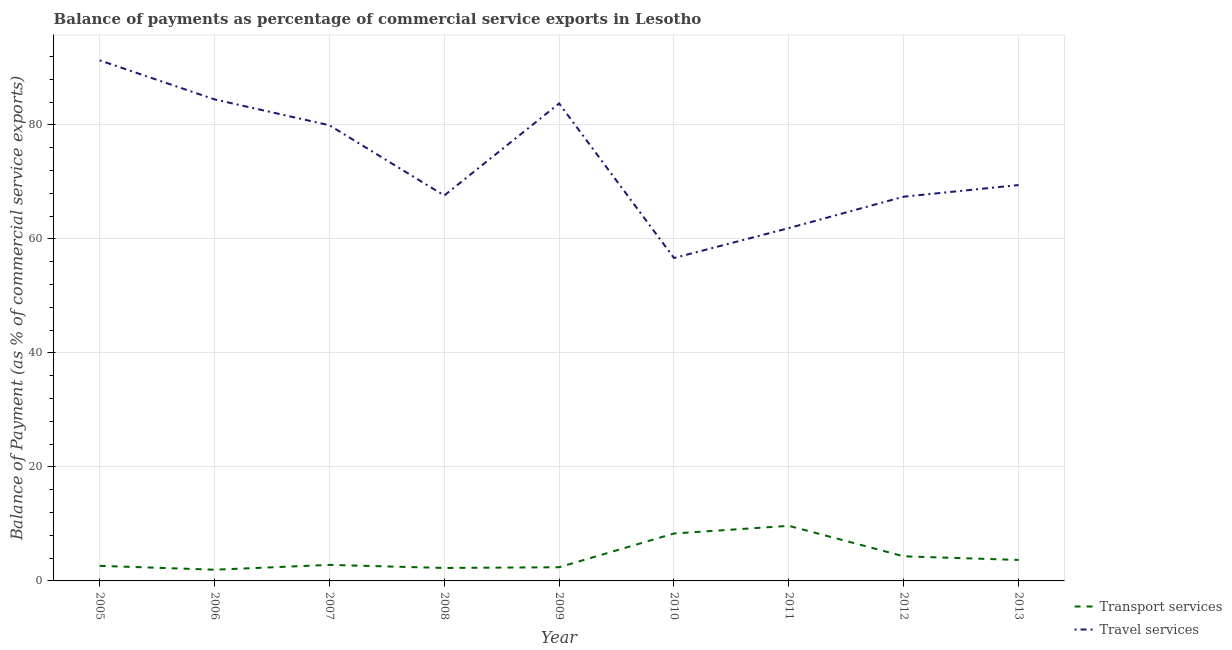Does the line corresponding to balance of payments of transport services intersect with the line corresponding to balance of payments of travel services?
Offer a very short reply. No. What is the balance of payments of travel services in 2009?
Make the answer very short. 83.77. Across all years, what is the maximum balance of payments of transport services?
Provide a succinct answer. 9.67. Across all years, what is the minimum balance of payments of travel services?
Provide a short and direct response. 56.66. What is the total balance of payments of travel services in the graph?
Your response must be concise. 662.61. What is the difference between the balance of payments of travel services in 2008 and that in 2011?
Keep it short and to the point. 5.71. What is the difference between the balance of payments of transport services in 2010 and the balance of payments of travel services in 2008?
Make the answer very short. -59.3. What is the average balance of payments of transport services per year?
Keep it short and to the point. 4.23. In the year 2008, what is the difference between the balance of payments of transport services and balance of payments of travel services?
Your response must be concise. -65.34. What is the ratio of the balance of payments of transport services in 2005 to that in 2008?
Provide a succinct answer. 1.16. Is the balance of payments of travel services in 2010 less than that in 2013?
Ensure brevity in your answer.  Yes. What is the difference between the highest and the second highest balance of payments of transport services?
Give a very brief answer. 1.34. What is the difference between the highest and the lowest balance of payments of transport services?
Keep it short and to the point. 7.7. Is the sum of the balance of payments of transport services in 2010 and 2013 greater than the maximum balance of payments of travel services across all years?
Keep it short and to the point. No. Is the balance of payments of transport services strictly less than the balance of payments of travel services over the years?
Provide a short and direct response. Yes. How many lines are there?
Make the answer very short. 2. Are the values on the major ticks of Y-axis written in scientific E-notation?
Your answer should be very brief. No. How many legend labels are there?
Offer a terse response. 2. What is the title of the graph?
Your answer should be very brief. Balance of payments as percentage of commercial service exports in Lesotho. Does "Nitrous oxide emissions" appear as one of the legend labels in the graph?
Ensure brevity in your answer.  No. What is the label or title of the X-axis?
Offer a very short reply. Year. What is the label or title of the Y-axis?
Make the answer very short. Balance of Payment (as % of commercial service exports). What is the Balance of Payment (as % of commercial service exports) of Transport services in 2005?
Provide a succinct answer. 2.64. What is the Balance of Payment (as % of commercial service exports) of Travel services in 2005?
Provide a succinct answer. 91.34. What is the Balance of Payment (as % of commercial service exports) of Transport services in 2006?
Your answer should be compact. 1.97. What is the Balance of Payment (as % of commercial service exports) in Travel services in 2006?
Make the answer very short. 84.49. What is the Balance of Payment (as % of commercial service exports) in Transport services in 2007?
Offer a terse response. 2.81. What is the Balance of Payment (as % of commercial service exports) in Travel services in 2007?
Your response must be concise. 79.95. What is the Balance of Payment (as % of commercial service exports) of Transport services in 2008?
Give a very brief answer. 2.27. What is the Balance of Payment (as % of commercial service exports) of Travel services in 2008?
Your response must be concise. 67.62. What is the Balance of Payment (as % of commercial service exports) of Transport services in 2009?
Your answer should be very brief. 2.4. What is the Balance of Payment (as % of commercial service exports) of Travel services in 2009?
Keep it short and to the point. 83.77. What is the Balance of Payment (as % of commercial service exports) in Transport services in 2010?
Provide a short and direct response. 8.32. What is the Balance of Payment (as % of commercial service exports) of Travel services in 2010?
Provide a succinct answer. 56.66. What is the Balance of Payment (as % of commercial service exports) in Transport services in 2011?
Provide a succinct answer. 9.67. What is the Balance of Payment (as % of commercial service exports) in Travel services in 2011?
Ensure brevity in your answer.  61.91. What is the Balance of Payment (as % of commercial service exports) of Transport services in 2012?
Give a very brief answer. 4.32. What is the Balance of Payment (as % of commercial service exports) in Travel services in 2012?
Your response must be concise. 67.42. What is the Balance of Payment (as % of commercial service exports) in Transport services in 2013?
Keep it short and to the point. 3.68. What is the Balance of Payment (as % of commercial service exports) of Travel services in 2013?
Your answer should be very brief. 69.46. Across all years, what is the maximum Balance of Payment (as % of commercial service exports) of Transport services?
Give a very brief answer. 9.67. Across all years, what is the maximum Balance of Payment (as % of commercial service exports) in Travel services?
Your response must be concise. 91.34. Across all years, what is the minimum Balance of Payment (as % of commercial service exports) in Transport services?
Make the answer very short. 1.97. Across all years, what is the minimum Balance of Payment (as % of commercial service exports) in Travel services?
Ensure brevity in your answer.  56.66. What is the total Balance of Payment (as % of commercial service exports) in Transport services in the graph?
Your answer should be very brief. 38.09. What is the total Balance of Payment (as % of commercial service exports) in Travel services in the graph?
Provide a succinct answer. 662.61. What is the difference between the Balance of Payment (as % of commercial service exports) of Transport services in 2005 and that in 2006?
Give a very brief answer. 0.68. What is the difference between the Balance of Payment (as % of commercial service exports) of Travel services in 2005 and that in 2006?
Give a very brief answer. 6.85. What is the difference between the Balance of Payment (as % of commercial service exports) in Transport services in 2005 and that in 2007?
Provide a succinct answer. -0.17. What is the difference between the Balance of Payment (as % of commercial service exports) in Travel services in 2005 and that in 2007?
Give a very brief answer. 11.39. What is the difference between the Balance of Payment (as % of commercial service exports) in Transport services in 2005 and that in 2008?
Your response must be concise. 0.37. What is the difference between the Balance of Payment (as % of commercial service exports) of Travel services in 2005 and that in 2008?
Provide a short and direct response. 23.72. What is the difference between the Balance of Payment (as % of commercial service exports) in Transport services in 2005 and that in 2009?
Keep it short and to the point. 0.24. What is the difference between the Balance of Payment (as % of commercial service exports) in Travel services in 2005 and that in 2009?
Offer a very short reply. 7.57. What is the difference between the Balance of Payment (as % of commercial service exports) in Transport services in 2005 and that in 2010?
Your answer should be compact. -5.68. What is the difference between the Balance of Payment (as % of commercial service exports) in Travel services in 2005 and that in 2010?
Offer a very short reply. 34.68. What is the difference between the Balance of Payment (as % of commercial service exports) of Transport services in 2005 and that in 2011?
Your response must be concise. -7.02. What is the difference between the Balance of Payment (as % of commercial service exports) in Travel services in 2005 and that in 2011?
Give a very brief answer. 29.43. What is the difference between the Balance of Payment (as % of commercial service exports) of Transport services in 2005 and that in 2012?
Your response must be concise. -1.67. What is the difference between the Balance of Payment (as % of commercial service exports) in Travel services in 2005 and that in 2012?
Your response must be concise. 23.92. What is the difference between the Balance of Payment (as % of commercial service exports) of Transport services in 2005 and that in 2013?
Provide a short and direct response. -1.04. What is the difference between the Balance of Payment (as % of commercial service exports) in Travel services in 2005 and that in 2013?
Give a very brief answer. 21.88. What is the difference between the Balance of Payment (as % of commercial service exports) in Transport services in 2006 and that in 2007?
Keep it short and to the point. -0.84. What is the difference between the Balance of Payment (as % of commercial service exports) of Travel services in 2006 and that in 2007?
Your response must be concise. 4.54. What is the difference between the Balance of Payment (as % of commercial service exports) in Transport services in 2006 and that in 2008?
Your answer should be very brief. -0.31. What is the difference between the Balance of Payment (as % of commercial service exports) of Travel services in 2006 and that in 2008?
Make the answer very short. 16.87. What is the difference between the Balance of Payment (as % of commercial service exports) in Transport services in 2006 and that in 2009?
Make the answer very short. -0.43. What is the difference between the Balance of Payment (as % of commercial service exports) of Travel services in 2006 and that in 2009?
Your answer should be very brief. 0.72. What is the difference between the Balance of Payment (as % of commercial service exports) in Transport services in 2006 and that in 2010?
Your answer should be compact. -6.35. What is the difference between the Balance of Payment (as % of commercial service exports) in Travel services in 2006 and that in 2010?
Your answer should be very brief. 27.83. What is the difference between the Balance of Payment (as % of commercial service exports) of Transport services in 2006 and that in 2011?
Give a very brief answer. -7.7. What is the difference between the Balance of Payment (as % of commercial service exports) of Travel services in 2006 and that in 2011?
Your answer should be very brief. 22.58. What is the difference between the Balance of Payment (as % of commercial service exports) in Transport services in 2006 and that in 2012?
Your answer should be compact. -2.35. What is the difference between the Balance of Payment (as % of commercial service exports) in Travel services in 2006 and that in 2012?
Provide a short and direct response. 17.07. What is the difference between the Balance of Payment (as % of commercial service exports) in Transport services in 2006 and that in 2013?
Your answer should be very brief. -1.71. What is the difference between the Balance of Payment (as % of commercial service exports) in Travel services in 2006 and that in 2013?
Your answer should be compact. 15.03. What is the difference between the Balance of Payment (as % of commercial service exports) of Transport services in 2007 and that in 2008?
Give a very brief answer. 0.54. What is the difference between the Balance of Payment (as % of commercial service exports) of Travel services in 2007 and that in 2008?
Your answer should be very brief. 12.33. What is the difference between the Balance of Payment (as % of commercial service exports) of Transport services in 2007 and that in 2009?
Your answer should be compact. 0.41. What is the difference between the Balance of Payment (as % of commercial service exports) in Travel services in 2007 and that in 2009?
Keep it short and to the point. -3.82. What is the difference between the Balance of Payment (as % of commercial service exports) of Transport services in 2007 and that in 2010?
Keep it short and to the point. -5.51. What is the difference between the Balance of Payment (as % of commercial service exports) in Travel services in 2007 and that in 2010?
Offer a terse response. 23.29. What is the difference between the Balance of Payment (as % of commercial service exports) in Transport services in 2007 and that in 2011?
Give a very brief answer. -6.85. What is the difference between the Balance of Payment (as % of commercial service exports) of Travel services in 2007 and that in 2011?
Offer a very short reply. 18.04. What is the difference between the Balance of Payment (as % of commercial service exports) in Transport services in 2007 and that in 2012?
Offer a very short reply. -1.5. What is the difference between the Balance of Payment (as % of commercial service exports) of Travel services in 2007 and that in 2012?
Make the answer very short. 12.53. What is the difference between the Balance of Payment (as % of commercial service exports) of Transport services in 2007 and that in 2013?
Make the answer very short. -0.87. What is the difference between the Balance of Payment (as % of commercial service exports) in Travel services in 2007 and that in 2013?
Your answer should be very brief. 10.5. What is the difference between the Balance of Payment (as % of commercial service exports) of Transport services in 2008 and that in 2009?
Give a very brief answer. -0.13. What is the difference between the Balance of Payment (as % of commercial service exports) in Travel services in 2008 and that in 2009?
Ensure brevity in your answer.  -16.15. What is the difference between the Balance of Payment (as % of commercial service exports) in Transport services in 2008 and that in 2010?
Give a very brief answer. -6.05. What is the difference between the Balance of Payment (as % of commercial service exports) of Travel services in 2008 and that in 2010?
Provide a short and direct response. 10.96. What is the difference between the Balance of Payment (as % of commercial service exports) in Transport services in 2008 and that in 2011?
Offer a very short reply. -7.39. What is the difference between the Balance of Payment (as % of commercial service exports) in Travel services in 2008 and that in 2011?
Offer a very short reply. 5.71. What is the difference between the Balance of Payment (as % of commercial service exports) in Transport services in 2008 and that in 2012?
Make the answer very short. -2.04. What is the difference between the Balance of Payment (as % of commercial service exports) in Travel services in 2008 and that in 2012?
Provide a short and direct response. 0.2. What is the difference between the Balance of Payment (as % of commercial service exports) of Transport services in 2008 and that in 2013?
Your response must be concise. -1.41. What is the difference between the Balance of Payment (as % of commercial service exports) in Travel services in 2008 and that in 2013?
Offer a terse response. -1.84. What is the difference between the Balance of Payment (as % of commercial service exports) in Transport services in 2009 and that in 2010?
Your answer should be very brief. -5.92. What is the difference between the Balance of Payment (as % of commercial service exports) in Travel services in 2009 and that in 2010?
Your answer should be compact. 27.11. What is the difference between the Balance of Payment (as % of commercial service exports) in Transport services in 2009 and that in 2011?
Provide a short and direct response. -7.26. What is the difference between the Balance of Payment (as % of commercial service exports) in Travel services in 2009 and that in 2011?
Offer a very short reply. 21.87. What is the difference between the Balance of Payment (as % of commercial service exports) in Transport services in 2009 and that in 2012?
Provide a succinct answer. -1.92. What is the difference between the Balance of Payment (as % of commercial service exports) of Travel services in 2009 and that in 2012?
Give a very brief answer. 16.36. What is the difference between the Balance of Payment (as % of commercial service exports) in Transport services in 2009 and that in 2013?
Provide a short and direct response. -1.28. What is the difference between the Balance of Payment (as % of commercial service exports) in Travel services in 2009 and that in 2013?
Keep it short and to the point. 14.32. What is the difference between the Balance of Payment (as % of commercial service exports) in Transport services in 2010 and that in 2011?
Make the answer very short. -1.34. What is the difference between the Balance of Payment (as % of commercial service exports) of Travel services in 2010 and that in 2011?
Offer a very short reply. -5.25. What is the difference between the Balance of Payment (as % of commercial service exports) in Transport services in 2010 and that in 2012?
Your response must be concise. 4. What is the difference between the Balance of Payment (as % of commercial service exports) in Travel services in 2010 and that in 2012?
Offer a terse response. -10.76. What is the difference between the Balance of Payment (as % of commercial service exports) in Transport services in 2010 and that in 2013?
Your answer should be very brief. 4.64. What is the difference between the Balance of Payment (as % of commercial service exports) of Travel services in 2010 and that in 2013?
Provide a succinct answer. -12.8. What is the difference between the Balance of Payment (as % of commercial service exports) of Transport services in 2011 and that in 2012?
Give a very brief answer. 5.35. What is the difference between the Balance of Payment (as % of commercial service exports) in Travel services in 2011 and that in 2012?
Your answer should be very brief. -5.51. What is the difference between the Balance of Payment (as % of commercial service exports) in Transport services in 2011 and that in 2013?
Offer a very short reply. 5.98. What is the difference between the Balance of Payment (as % of commercial service exports) in Travel services in 2011 and that in 2013?
Your answer should be compact. -7.55. What is the difference between the Balance of Payment (as % of commercial service exports) of Transport services in 2012 and that in 2013?
Offer a terse response. 0.64. What is the difference between the Balance of Payment (as % of commercial service exports) in Travel services in 2012 and that in 2013?
Provide a short and direct response. -2.04. What is the difference between the Balance of Payment (as % of commercial service exports) of Transport services in 2005 and the Balance of Payment (as % of commercial service exports) of Travel services in 2006?
Make the answer very short. -81.84. What is the difference between the Balance of Payment (as % of commercial service exports) in Transport services in 2005 and the Balance of Payment (as % of commercial service exports) in Travel services in 2007?
Offer a terse response. -77.31. What is the difference between the Balance of Payment (as % of commercial service exports) of Transport services in 2005 and the Balance of Payment (as % of commercial service exports) of Travel services in 2008?
Give a very brief answer. -64.97. What is the difference between the Balance of Payment (as % of commercial service exports) in Transport services in 2005 and the Balance of Payment (as % of commercial service exports) in Travel services in 2009?
Make the answer very short. -81.13. What is the difference between the Balance of Payment (as % of commercial service exports) in Transport services in 2005 and the Balance of Payment (as % of commercial service exports) in Travel services in 2010?
Provide a succinct answer. -54.01. What is the difference between the Balance of Payment (as % of commercial service exports) of Transport services in 2005 and the Balance of Payment (as % of commercial service exports) of Travel services in 2011?
Offer a terse response. -59.26. What is the difference between the Balance of Payment (as % of commercial service exports) of Transport services in 2005 and the Balance of Payment (as % of commercial service exports) of Travel services in 2012?
Provide a short and direct response. -64.77. What is the difference between the Balance of Payment (as % of commercial service exports) in Transport services in 2005 and the Balance of Payment (as % of commercial service exports) in Travel services in 2013?
Your answer should be compact. -66.81. What is the difference between the Balance of Payment (as % of commercial service exports) in Transport services in 2006 and the Balance of Payment (as % of commercial service exports) in Travel services in 2007?
Provide a succinct answer. -77.98. What is the difference between the Balance of Payment (as % of commercial service exports) of Transport services in 2006 and the Balance of Payment (as % of commercial service exports) of Travel services in 2008?
Your answer should be very brief. -65.65. What is the difference between the Balance of Payment (as % of commercial service exports) of Transport services in 2006 and the Balance of Payment (as % of commercial service exports) of Travel services in 2009?
Your answer should be very brief. -81.8. What is the difference between the Balance of Payment (as % of commercial service exports) in Transport services in 2006 and the Balance of Payment (as % of commercial service exports) in Travel services in 2010?
Your response must be concise. -54.69. What is the difference between the Balance of Payment (as % of commercial service exports) of Transport services in 2006 and the Balance of Payment (as % of commercial service exports) of Travel services in 2011?
Ensure brevity in your answer.  -59.94. What is the difference between the Balance of Payment (as % of commercial service exports) of Transport services in 2006 and the Balance of Payment (as % of commercial service exports) of Travel services in 2012?
Your answer should be very brief. -65.45. What is the difference between the Balance of Payment (as % of commercial service exports) in Transport services in 2006 and the Balance of Payment (as % of commercial service exports) in Travel services in 2013?
Offer a terse response. -67.49. What is the difference between the Balance of Payment (as % of commercial service exports) of Transport services in 2007 and the Balance of Payment (as % of commercial service exports) of Travel services in 2008?
Offer a very short reply. -64.81. What is the difference between the Balance of Payment (as % of commercial service exports) in Transport services in 2007 and the Balance of Payment (as % of commercial service exports) in Travel services in 2009?
Keep it short and to the point. -80.96. What is the difference between the Balance of Payment (as % of commercial service exports) of Transport services in 2007 and the Balance of Payment (as % of commercial service exports) of Travel services in 2010?
Your response must be concise. -53.85. What is the difference between the Balance of Payment (as % of commercial service exports) of Transport services in 2007 and the Balance of Payment (as % of commercial service exports) of Travel services in 2011?
Your answer should be very brief. -59.09. What is the difference between the Balance of Payment (as % of commercial service exports) in Transport services in 2007 and the Balance of Payment (as % of commercial service exports) in Travel services in 2012?
Your answer should be very brief. -64.6. What is the difference between the Balance of Payment (as % of commercial service exports) in Transport services in 2007 and the Balance of Payment (as % of commercial service exports) in Travel services in 2013?
Give a very brief answer. -66.64. What is the difference between the Balance of Payment (as % of commercial service exports) in Transport services in 2008 and the Balance of Payment (as % of commercial service exports) in Travel services in 2009?
Your answer should be very brief. -81.5. What is the difference between the Balance of Payment (as % of commercial service exports) in Transport services in 2008 and the Balance of Payment (as % of commercial service exports) in Travel services in 2010?
Ensure brevity in your answer.  -54.38. What is the difference between the Balance of Payment (as % of commercial service exports) in Transport services in 2008 and the Balance of Payment (as % of commercial service exports) in Travel services in 2011?
Offer a terse response. -59.63. What is the difference between the Balance of Payment (as % of commercial service exports) in Transport services in 2008 and the Balance of Payment (as % of commercial service exports) in Travel services in 2012?
Ensure brevity in your answer.  -65.14. What is the difference between the Balance of Payment (as % of commercial service exports) of Transport services in 2008 and the Balance of Payment (as % of commercial service exports) of Travel services in 2013?
Provide a succinct answer. -67.18. What is the difference between the Balance of Payment (as % of commercial service exports) of Transport services in 2009 and the Balance of Payment (as % of commercial service exports) of Travel services in 2010?
Your answer should be compact. -54.26. What is the difference between the Balance of Payment (as % of commercial service exports) in Transport services in 2009 and the Balance of Payment (as % of commercial service exports) in Travel services in 2011?
Offer a terse response. -59.5. What is the difference between the Balance of Payment (as % of commercial service exports) of Transport services in 2009 and the Balance of Payment (as % of commercial service exports) of Travel services in 2012?
Your response must be concise. -65.01. What is the difference between the Balance of Payment (as % of commercial service exports) of Transport services in 2009 and the Balance of Payment (as % of commercial service exports) of Travel services in 2013?
Provide a succinct answer. -67.05. What is the difference between the Balance of Payment (as % of commercial service exports) of Transport services in 2010 and the Balance of Payment (as % of commercial service exports) of Travel services in 2011?
Provide a short and direct response. -53.58. What is the difference between the Balance of Payment (as % of commercial service exports) of Transport services in 2010 and the Balance of Payment (as % of commercial service exports) of Travel services in 2012?
Offer a terse response. -59.09. What is the difference between the Balance of Payment (as % of commercial service exports) in Transport services in 2010 and the Balance of Payment (as % of commercial service exports) in Travel services in 2013?
Keep it short and to the point. -61.13. What is the difference between the Balance of Payment (as % of commercial service exports) of Transport services in 2011 and the Balance of Payment (as % of commercial service exports) of Travel services in 2012?
Offer a terse response. -57.75. What is the difference between the Balance of Payment (as % of commercial service exports) in Transport services in 2011 and the Balance of Payment (as % of commercial service exports) in Travel services in 2013?
Ensure brevity in your answer.  -59.79. What is the difference between the Balance of Payment (as % of commercial service exports) in Transport services in 2012 and the Balance of Payment (as % of commercial service exports) in Travel services in 2013?
Offer a very short reply. -65.14. What is the average Balance of Payment (as % of commercial service exports) of Transport services per year?
Make the answer very short. 4.23. What is the average Balance of Payment (as % of commercial service exports) in Travel services per year?
Ensure brevity in your answer.  73.62. In the year 2005, what is the difference between the Balance of Payment (as % of commercial service exports) of Transport services and Balance of Payment (as % of commercial service exports) of Travel services?
Ensure brevity in your answer.  -88.69. In the year 2006, what is the difference between the Balance of Payment (as % of commercial service exports) in Transport services and Balance of Payment (as % of commercial service exports) in Travel services?
Provide a succinct answer. -82.52. In the year 2007, what is the difference between the Balance of Payment (as % of commercial service exports) of Transport services and Balance of Payment (as % of commercial service exports) of Travel services?
Keep it short and to the point. -77.14. In the year 2008, what is the difference between the Balance of Payment (as % of commercial service exports) of Transport services and Balance of Payment (as % of commercial service exports) of Travel services?
Offer a terse response. -65.34. In the year 2009, what is the difference between the Balance of Payment (as % of commercial service exports) of Transport services and Balance of Payment (as % of commercial service exports) of Travel services?
Ensure brevity in your answer.  -81.37. In the year 2010, what is the difference between the Balance of Payment (as % of commercial service exports) of Transport services and Balance of Payment (as % of commercial service exports) of Travel services?
Make the answer very short. -48.34. In the year 2011, what is the difference between the Balance of Payment (as % of commercial service exports) of Transport services and Balance of Payment (as % of commercial service exports) of Travel services?
Provide a short and direct response. -52.24. In the year 2012, what is the difference between the Balance of Payment (as % of commercial service exports) in Transport services and Balance of Payment (as % of commercial service exports) in Travel services?
Offer a very short reply. -63.1. In the year 2013, what is the difference between the Balance of Payment (as % of commercial service exports) of Transport services and Balance of Payment (as % of commercial service exports) of Travel services?
Keep it short and to the point. -65.77. What is the ratio of the Balance of Payment (as % of commercial service exports) in Transport services in 2005 to that in 2006?
Provide a succinct answer. 1.34. What is the ratio of the Balance of Payment (as % of commercial service exports) in Travel services in 2005 to that in 2006?
Keep it short and to the point. 1.08. What is the ratio of the Balance of Payment (as % of commercial service exports) of Transport services in 2005 to that in 2007?
Offer a very short reply. 0.94. What is the ratio of the Balance of Payment (as % of commercial service exports) in Travel services in 2005 to that in 2007?
Offer a terse response. 1.14. What is the ratio of the Balance of Payment (as % of commercial service exports) in Transport services in 2005 to that in 2008?
Ensure brevity in your answer.  1.16. What is the ratio of the Balance of Payment (as % of commercial service exports) of Travel services in 2005 to that in 2008?
Provide a short and direct response. 1.35. What is the ratio of the Balance of Payment (as % of commercial service exports) of Transport services in 2005 to that in 2009?
Give a very brief answer. 1.1. What is the ratio of the Balance of Payment (as % of commercial service exports) in Travel services in 2005 to that in 2009?
Offer a very short reply. 1.09. What is the ratio of the Balance of Payment (as % of commercial service exports) of Transport services in 2005 to that in 2010?
Your answer should be compact. 0.32. What is the ratio of the Balance of Payment (as % of commercial service exports) in Travel services in 2005 to that in 2010?
Make the answer very short. 1.61. What is the ratio of the Balance of Payment (as % of commercial service exports) in Transport services in 2005 to that in 2011?
Offer a very short reply. 0.27. What is the ratio of the Balance of Payment (as % of commercial service exports) in Travel services in 2005 to that in 2011?
Offer a very short reply. 1.48. What is the ratio of the Balance of Payment (as % of commercial service exports) of Transport services in 2005 to that in 2012?
Keep it short and to the point. 0.61. What is the ratio of the Balance of Payment (as % of commercial service exports) in Travel services in 2005 to that in 2012?
Offer a very short reply. 1.35. What is the ratio of the Balance of Payment (as % of commercial service exports) of Transport services in 2005 to that in 2013?
Keep it short and to the point. 0.72. What is the ratio of the Balance of Payment (as % of commercial service exports) of Travel services in 2005 to that in 2013?
Provide a succinct answer. 1.32. What is the ratio of the Balance of Payment (as % of commercial service exports) of Transport services in 2006 to that in 2007?
Your answer should be compact. 0.7. What is the ratio of the Balance of Payment (as % of commercial service exports) in Travel services in 2006 to that in 2007?
Provide a short and direct response. 1.06. What is the ratio of the Balance of Payment (as % of commercial service exports) in Transport services in 2006 to that in 2008?
Your response must be concise. 0.87. What is the ratio of the Balance of Payment (as % of commercial service exports) in Travel services in 2006 to that in 2008?
Your answer should be compact. 1.25. What is the ratio of the Balance of Payment (as % of commercial service exports) of Transport services in 2006 to that in 2009?
Offer a very short reply. 0.82. What is the ratio of the Balance of Payment (as % of commercial service exports) of Travel services in 2006 to that in 2009?
Provide a short and direct response. 1.01. What is the ratio of the Balance of Payment (as % of commercial service exports) of Transport services in 2006 to that in 2010?
Offer a very short reply. 0.24. What is the ratio of the Balance of Payment (as % of commercial service exports) in Travel services in 2006 to that in 2010?
Your answer should be very brief. 1.49. What is the ratio of the Balance of Payment (as % of commercial service exports) of Transport services in 2006 to that in 2011?
Offer a very short reply. 0.2. What is the ratio of the Balance of Payment (as % of commercial service exports) in Travel services in 2006 to that in 2011?
Give a very brief answer. 1.36. What is the ratio of the Balance of Payment (as % of commercial service exports) in Transport services in 2006 to that in 2012?
Keep it short and to the point. 0.46. What is the ratio of the Balance of Payment (as % of commercial service exports) in Travel services in 2006 to that in 2012?
Ensure brevity in your answer.  1.25. What is the ratio of the Balance of Payment (as % of commercial service exports) in Transport services in 2006 to that in 2013?
Give a very brief answer. 0.53. What is the ratio of the Balance of Payment (as % of commercial service exports) of Travel services in 2006 to that in 2013?
Provide a succinct answer. 1.22. What is the ratio of the Balance of Payment (as % of commercial service exports) of Transport services in 2007 to that in 2008?
Keep it short and to the point. 1.24. What is the ratio of the Balance of Payment (as % of commercial service exports) in Travel services in 2007 to that in 2008?
Provide a succinct answer. 1.18. What is the ratio of the Balance of Payment (as % of commercial service exports) of Transport services in 2007 to that in 2009?
Provide a short and direct response. 1.17. What is the ratio of the Balance of Payment (as % of commercial service exports) of Travel services in 2007 to that in 2009?
Offer a terse response. 0.95. What is the ratio of the Balance of Payment (as % of commercial service exports) of Transport services in 2007 to that in 2010?
Keep it short and to the point. 0.34. What is the ratio of the Balance of Payment (as % of commercial service exports) of Travel services in 2007 to that in 2010?
Give a very brief answer. 1.41. What is the ratio of the Balance of Payment (as % of commercial service exports) in Transport services in 2007 to that in 2011?
Ensure brevity in your answer.  0.29. What is the ratio of the Balance of Payment (as % of commercial service exports) of Travel services in 2007 to that in 2011?
Your response must be concise. 1.29. What is the ratio of the Balance of Payment (as % of commercial service exports) of Transport services in 2007 to that in 2012?
Give a very brief answer. 0.65. What is the ratio of the Balance of Payment (as % of commercial service exports) in Travel services in 2007 to that in 2012?
Ensure brevity in your answer.  1.19. What is the ratio of the Balance of Payment (as % of commercial service exports) in Transport services in 2007 to that in 2013?
Make the answer very short. 0.76. What is the ratio of the Balance of Payment (as % of commercial service exports) of Travel services in 2007 to that in 2013?
Your response must be concise. 1.15. What is the ratio of the Balance of Payment (as % of commercial service exports) in Transport services in 2008 to that in 2009?
Offer a very short reply. 0.95. What is the ratio of the Balance of Payment (as % of commercial service exports) of Travel services in 2008 to that in 2009?
Keep it short and to the point. 0.81. What is the ratio of the Balance of Payment (as % of commercial service exports) in Transport services in 2008 to that in 2010?
Provide a short and direct response. 0.27. What is the ratio of the Balance of Payment (as % of commercial service exports) of Travel services in 2008 to that in 2010?
Make the answer very short. 1.19. What is the ratio of the Balance of Payment (as % of commercial service exports) in Transport services in 2008 to that in 2011?
Make the answer very short. 0.24. What is the ratio of the Balance of Payment (as % of commercial service exports) of Travel services in 2008 to that in 2011?
Give a very brief answer. 1.09. What is the ratio of the Balance of Payment (as % of commercial service exports) of Transport services in 2008 to that in 2012?
Provide a succinct answer. 0.53. What is the ratio of the Balance of Payment (as % of commercial service exports) in Transport services in 2008 to that in 2013?
Offer a very short reply. 0.62. What is the ratio of the Balance of Payment (as % of commercial service exports) in Travel services in 2008 to that in 2013?
Offer a terse response. 0.97. What is the ratio of the Balance of Payment (as % of commercial service exports) in Transport services in 2009 to that in 2010?
Offer a terse response. 0.29. What is the ratio of the Balance of Payment (as % of commercial service exports) of Travel services in 2009 to that in 2010?
Your response must be concise. 1.48. What is the ratio of the Balance of Payment (as % of commercial service exports) of Transport services in 2009 to that in 2011?
Your answer should be compact. 0.25. What is the ratio of the Balance of Payment (as % of commercial service exports) in Travel services in 2009 to that in 2011?
Your answer should be compact. 1.35. What is the ratio of the Balance of Payment (as % of commercial service exports) of Transport services in 2009 to that in 2012?
Provide a succinct answer. 0.56. What is the ratio of the Balance of Payment (as % of commercial service exports) in Travel services in 2009 to that in 2012?
Your response must be concise. 1.24. What is the ratio of the Balance of Payment (as % of commercial service exports) in Transport services in 2009 to that in 2013?
Your answer should be compact. 0.65. What is the ratio of the Balance of Payment (as % of commercial service exports) in Travel services in 2009 to that in 2013?
Provide a succinct answer. 1.21. What is the ratio of the Balance of Payment (as % of commercial service exports) in Transport services in 2010 to that in 2011?
Offer a terse response. 0.86. What is the ratio of the Balance of Payment (as % of commercial service exports) of Travel services in 2010 to that in 2011?
Offer a very short reply. 0.92. What is the ratio of the Balance of Payment (as % of commercial service exports) of Transport services in 2010 to that in 2012?
Offer a very short reply. 1.93. What is the ratio of the Balance of Payment (as % of commercial service exports) of Travel services in 2010 to that in 2012?
Ensure brevity in your answer.  0.84. What is the ratio of the Balance of Payment (as % of commercial service exports) in Transport services in 2010 to that in 2013?
Your answer should be compact. 2.26. What is the ratio of the Balance of Payment (as % of commercial service exports) in Travel services in 2010 to that in 2013?
Provide a short and direct response. 0.82. What is the ratio of the Balance of Payment (as % of commercial service exports) in Transport services in 2011 to that in 2012?
Offer a very short reply. 2.24. What is the ratio of the Balance of Payment (as % of commercial service exports) of Travel services in 2011 to that in 2012?
Provide a short and direct response. 0.92. What is the ratio of the Balance of Payment (as % of commercial service exports) in Transport services in 2011 to that in 2013?
Provide a succinct answer. 2.63. What is the ratio of the Balance of Payment (as % of commercial service exports) of Travel services in 2011 to that in 2013?
Your answer should be very brief. 0.89. What is the ratio of the Balance of Payment (as % of commercial service exports) in Transport services in 2012 to that in 2013?
Provide a short and direct response. 1.17. What is the ratio of the Balance of Payment (as % of commercial service exports) of Travel services in 2012 to that in 2013?
Offer a very short reply. 0.97. What is the difference between the highest and the second highest Balance of Payment (as % of commercial service exports) of Transport services?
Offer a very short reply. 1.34. What is the difference between the highest and the second highest Balance of Payment (as % of commercial service exports) in Travel services?
Offer a terse response. 6.85. What is the difference between the highest and the lowest Balance of Payment (as % of commercial service exports) of Transport services?
Give a very brief answer. 7.7. What is the difference between the highest and the lowest Balance of Payment (as % of commercial service exports) of Travel services?
Give a very brief answer. 34.68. 